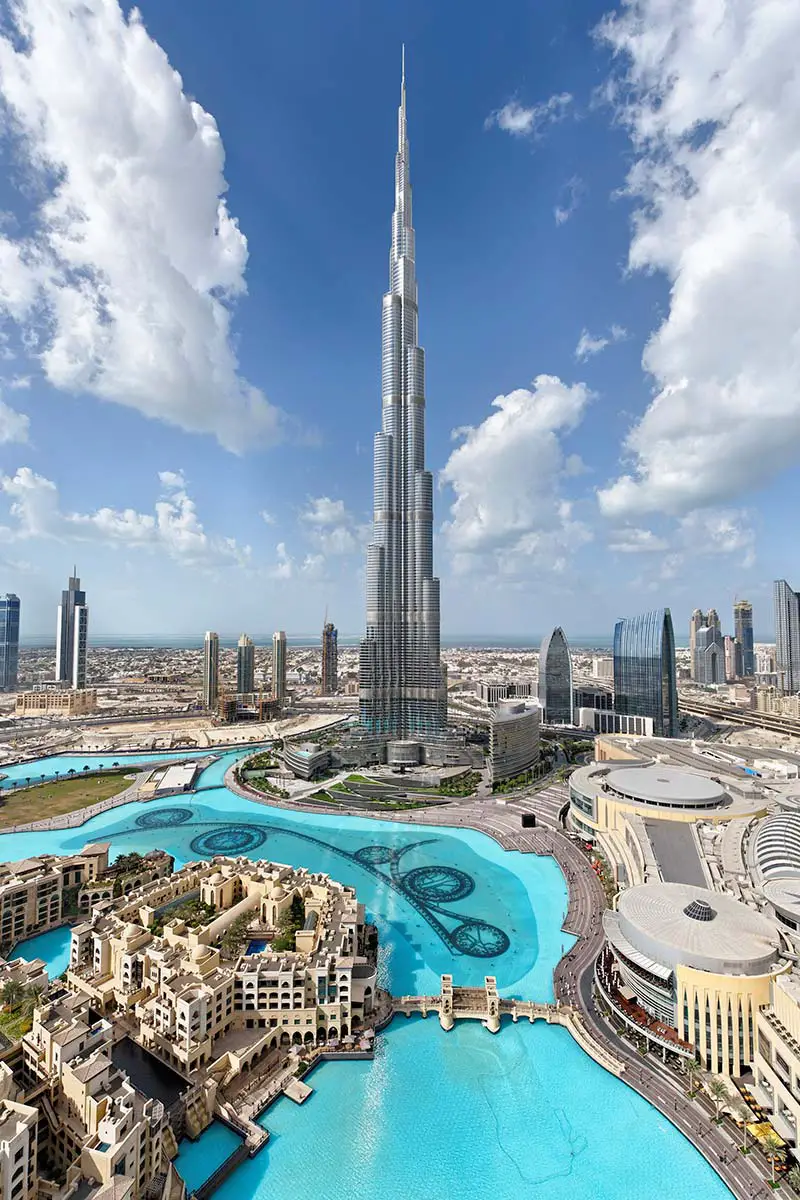What futuristic upgrades could be integrated into the Burj Khalifa? In the future, the Burj Khalifa could potentially integrate numerous advanced technologies to enhance its functionality and sustainability. Imagine an energy harvesting system that captures and converts wind and solar energy, making the structure entirely self-sufficient. Smart glass windows that adjust their transparency to control internal temperatures could reduce energy consumption. Autonomous drones might be deployed for maintenance and cleaning tasks, ensuring the building always looks pristine. An AI-controlled smart hub could manage all aspects of the building’s operation, from security to resource management. Virtual reality could transform viewing decks into portals that offer a spectacular experience of being anywhere around the world. Additionally, vertical gardens could be introduced to enhance air quality and bring a touch of nature to each floor. These upgrades would solidify Burj Khalifa's status as not only a marvel of engineering but also an exemplar of sustainable and futuristic living. 